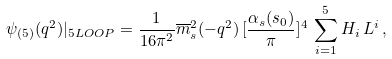Convert formula to latex. <formula><loc_0><loc_0><loc_500><loc_500>\psi _ { ( 5 ) } ( q ^ { 2 } ) | _ { 5 L O O P } = \frac { 1 } { 1 6 \pi ^ { 2 } } \overline { m } _ { s } ^ { 2 } ( - q ^ { 2 } ) \, [ \frac { \alpha _ { s } ( s _ { 0 } ) } { \pi } ] ^ { 4 } \, \sum _ { i = 1 } ^ { 5 } H _ { i } \, L ^ { i } \, ,</formula> 